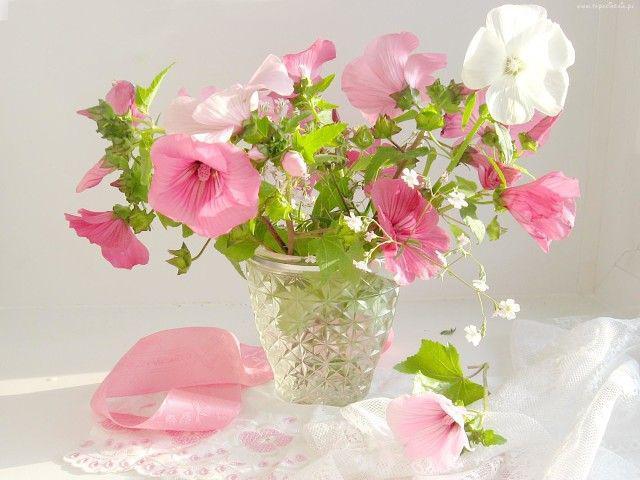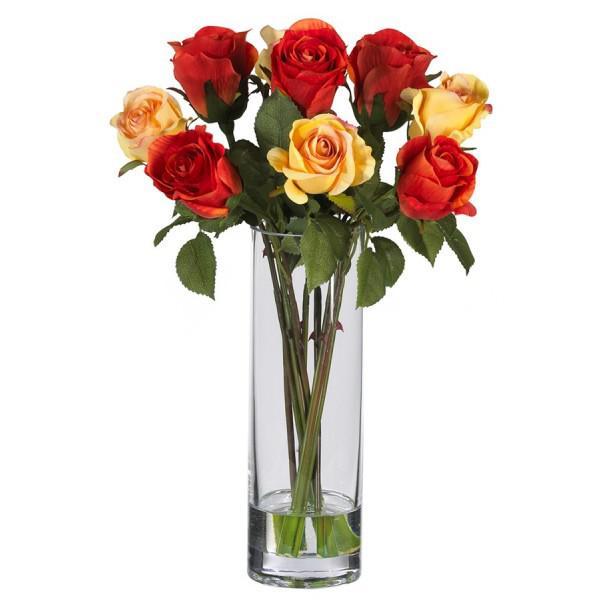The first image is the image on the left, the second image is the image on the right. Assess this claim about the two images: "there are roses in a clear glass vase that is the same width on the bottom as it is on the top". Correct or not? Answer yes or no. Yes. 